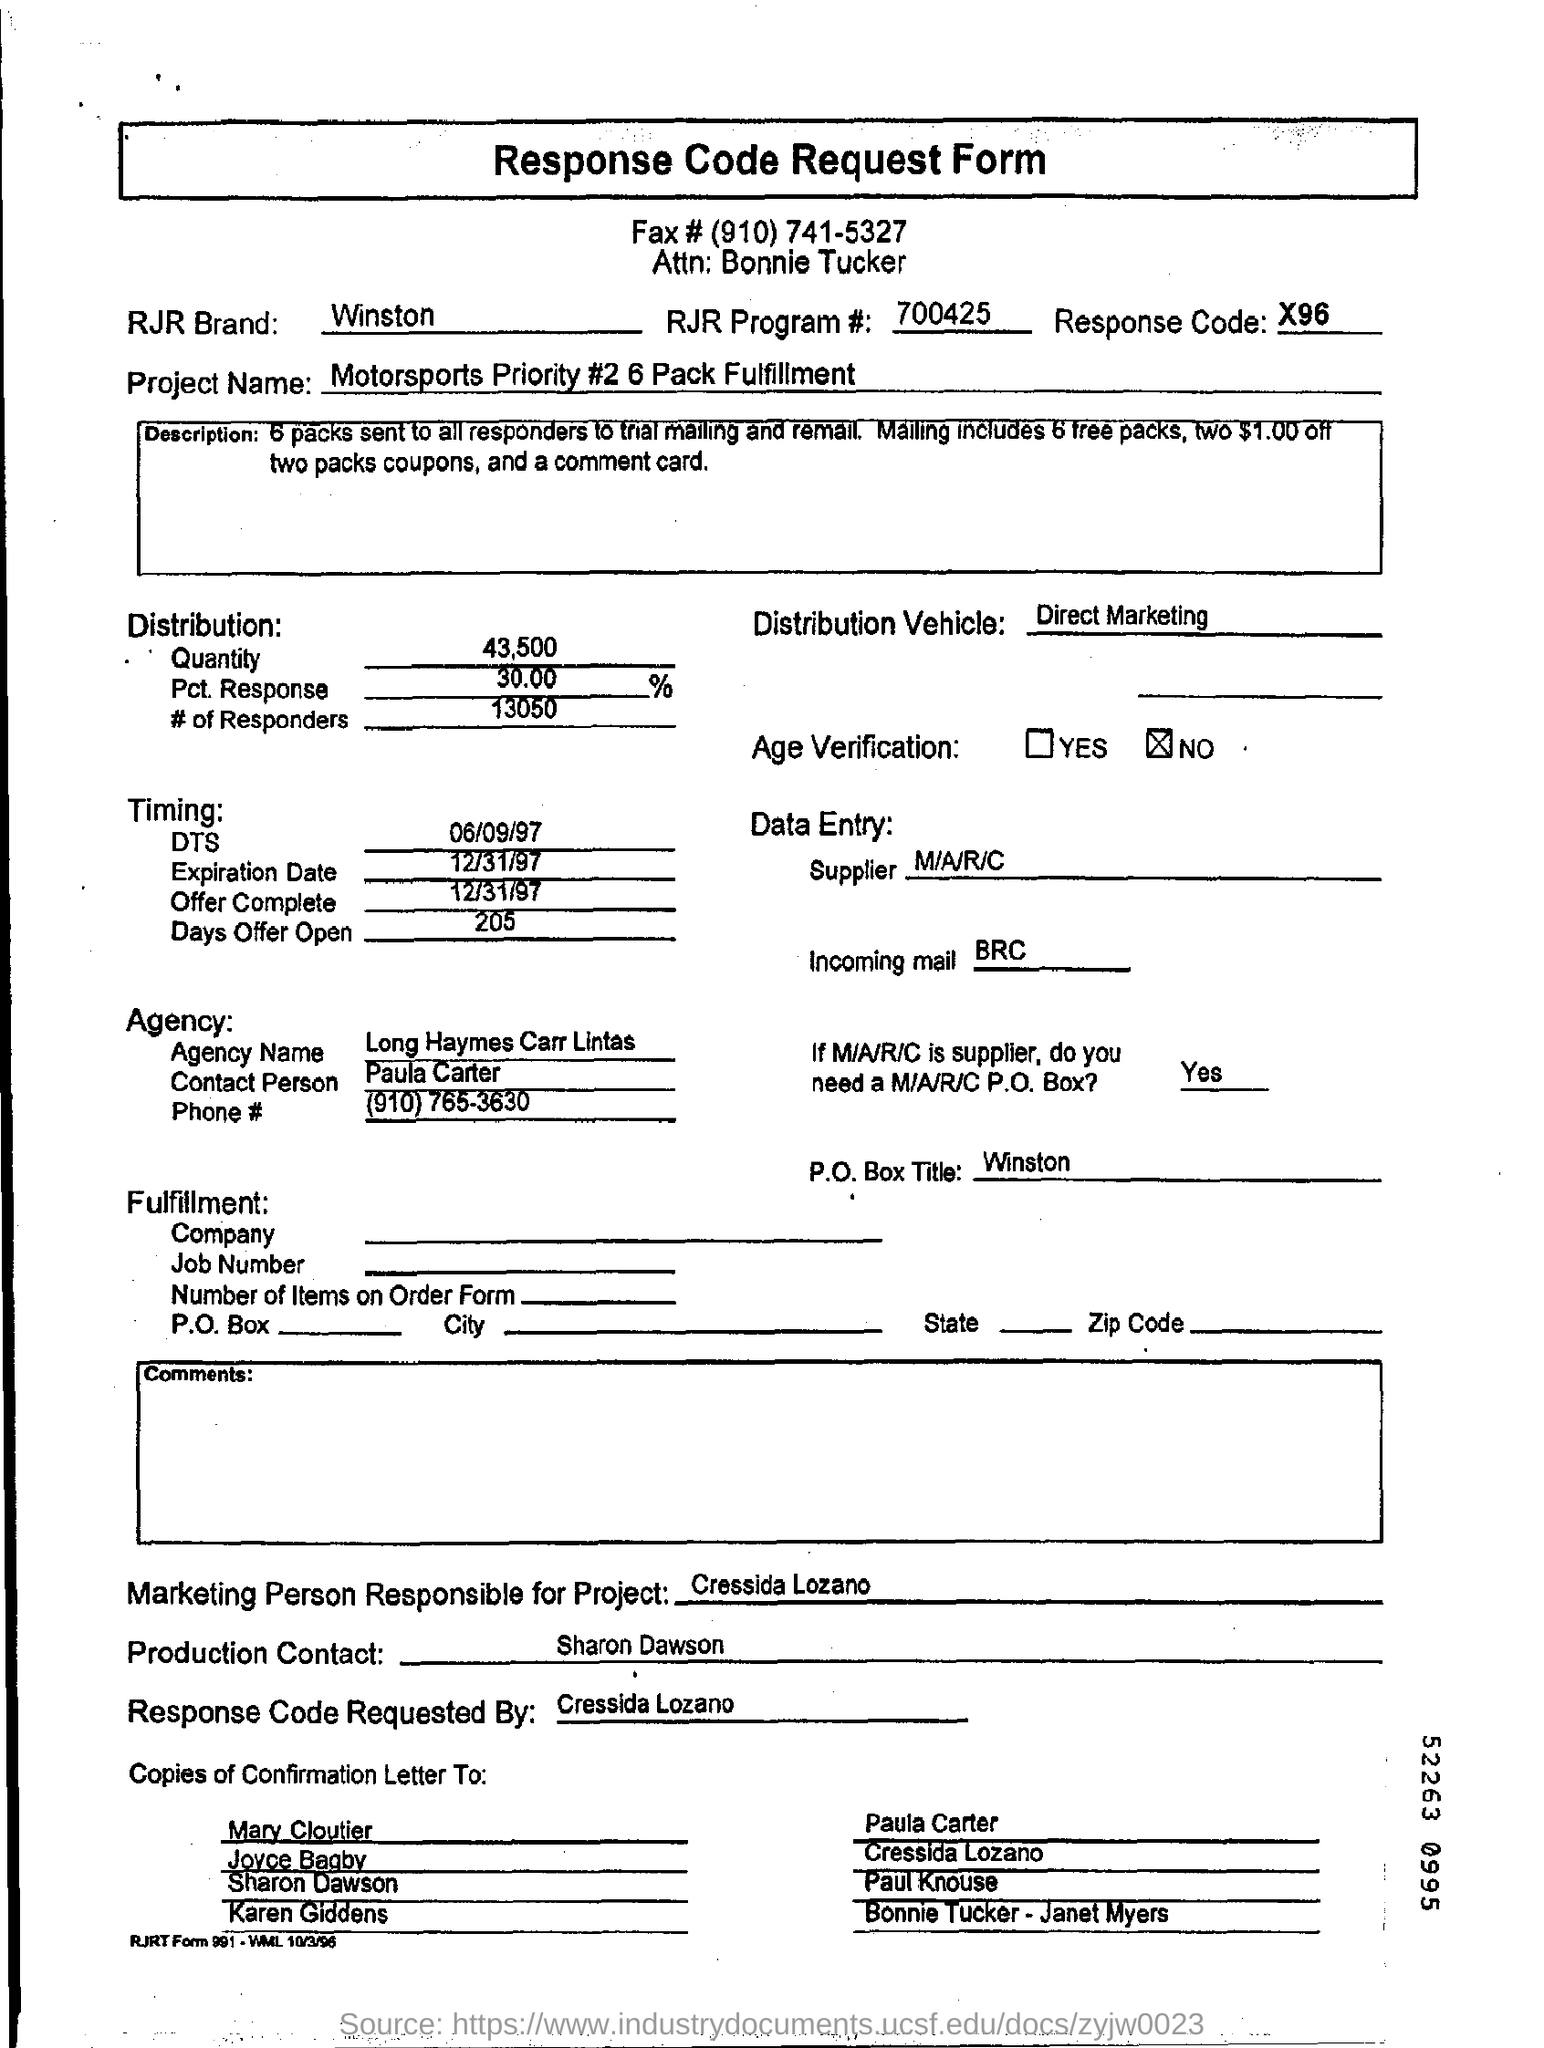What kind of form is this ?
Ensure brevity in your answer.  Response Code Request Form. What is the fax number given at the top of the form?
Provide a short and direct response. (910)741-5327. What is the name of the brand in the document?
Your answer should be compact. Winston. What is the response code ?
Offer a terse response. X96. What is the "Project Name"?
Keep it short and to the point. Motorsports priority #2 6 pack fulfillment. 